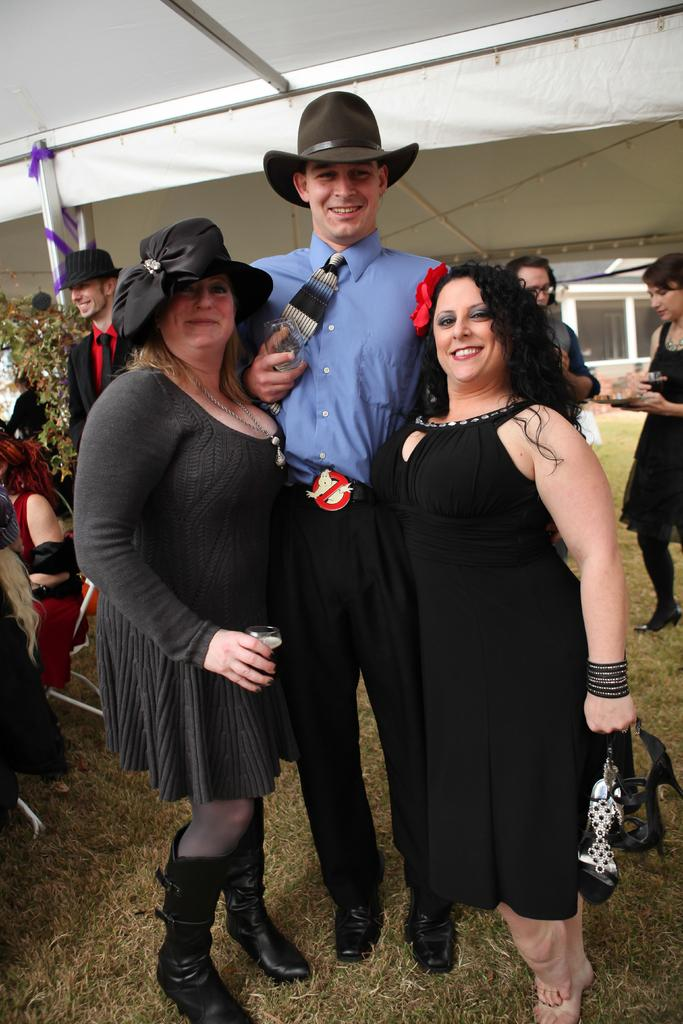What are the people in the image doing? The people in the image are standing on the grass. How are the people interacting with each other? The people are smiling at someone. What accessories are some people wearing? Some people are wearing hats. What can be seen in the background of the image? There are trees and windows in the background. Can you tell me how many snakes are slithering through the grass in the image? There are no snakes present in the image; it features people standing on the grass. What type of stretch is being performed by the people in the image? There is no stretch being performed by the people in the image; they are standing and smiling at someone. 